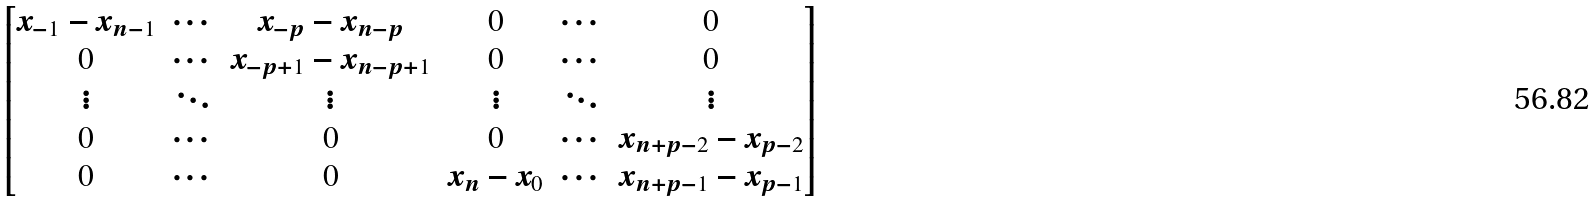Convert formula to latex. <formula><loc_0><loc_0><loc_500><loc_500>\begin{bmatrix} x _ { - 1 } - x _ { n - 1 } & \cdots & x _ { - p } - x _ { n - p } & 0 & \cdots & 0 \\ 0 & \cdots & x _ { - p + 1 } - x _ { n - p + 1 } & 0 & \cdots & 0 \\ \vdots & \ddots & \vdots & \vdots & \ddots & \vdots \\ 0 & \cdots & 0 & 0 & \cdots & x _ { n + p - 2 } - x _ { p - 2 } \\ 0 & \cdots & 0 & x _ { n } - x _ { 0 } & \cdots & x _ { n + p - 1 } - x _ { p - 1 } \end{bmatrix}</formula> 